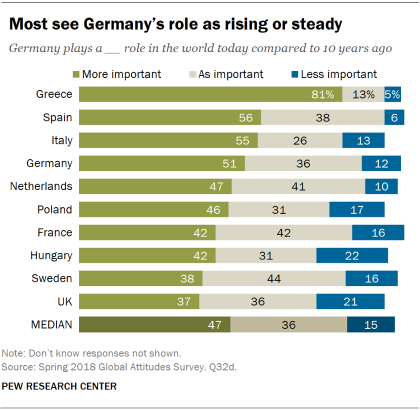Mention a couple of crucial points in this snapshot. The average of all the more important bars, excluding the median, is 0.495. The blue bars represent less important information. 